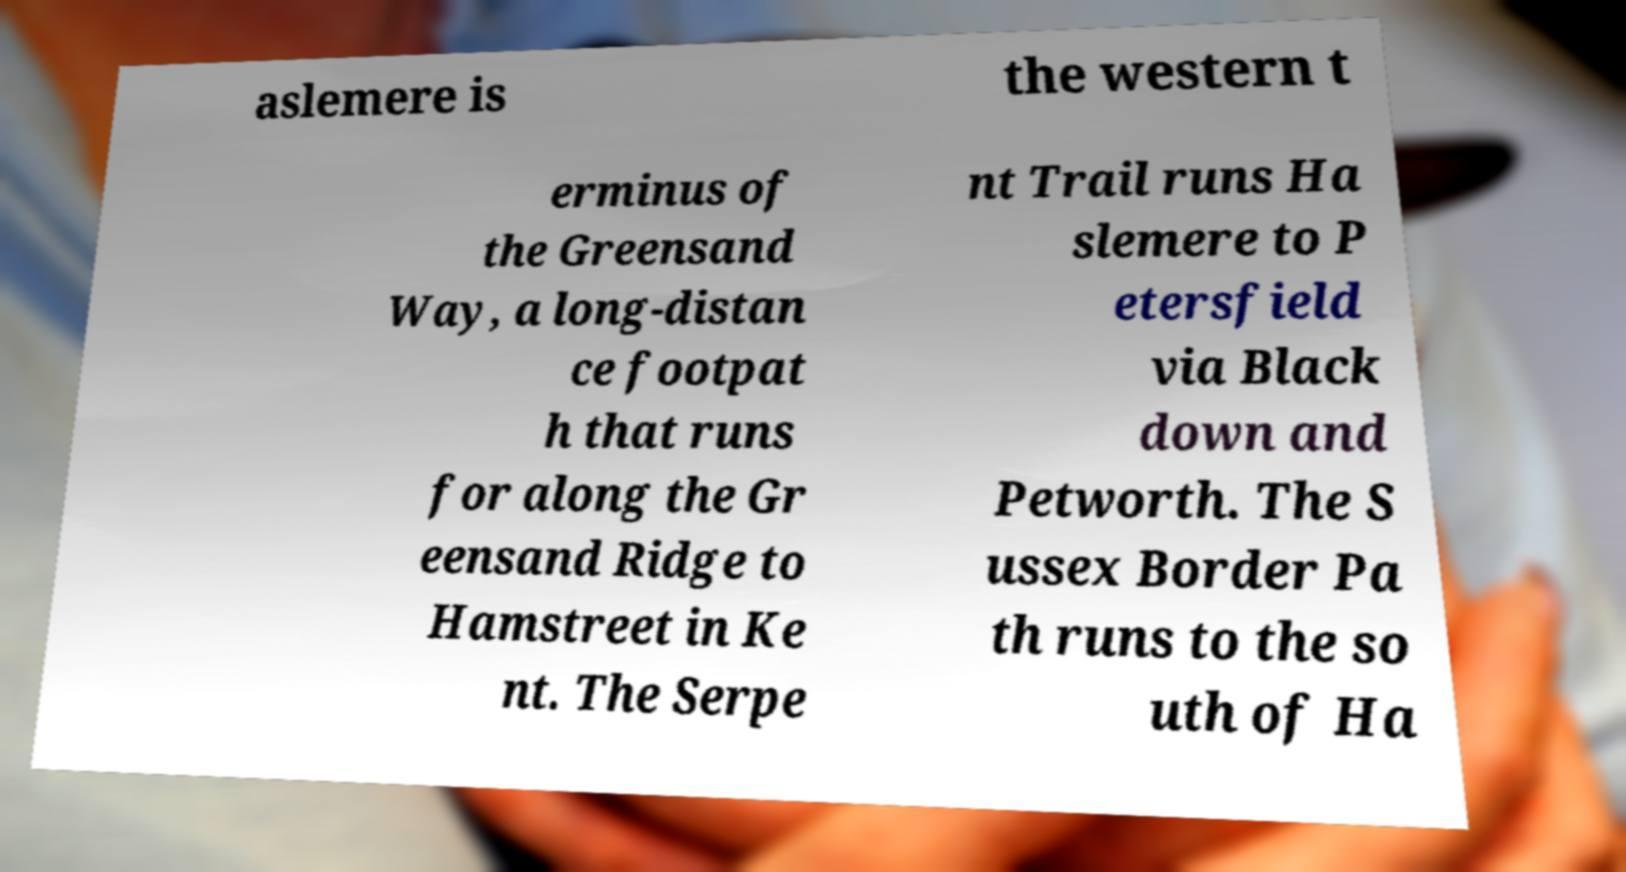Could you assist in decoding the text presented in this image and type it out clearly? aslemere is the western t erminus of the Greensand Way, a long-distan ce footpat h that runs for along the Gr eensand Ridge to Hamstreet in Ke nt. The Serpe nt Trail runs Ha slemere to P etersfield via Black down and Petworth. The S ussex Border Pa th runs to the so uth of Ha 